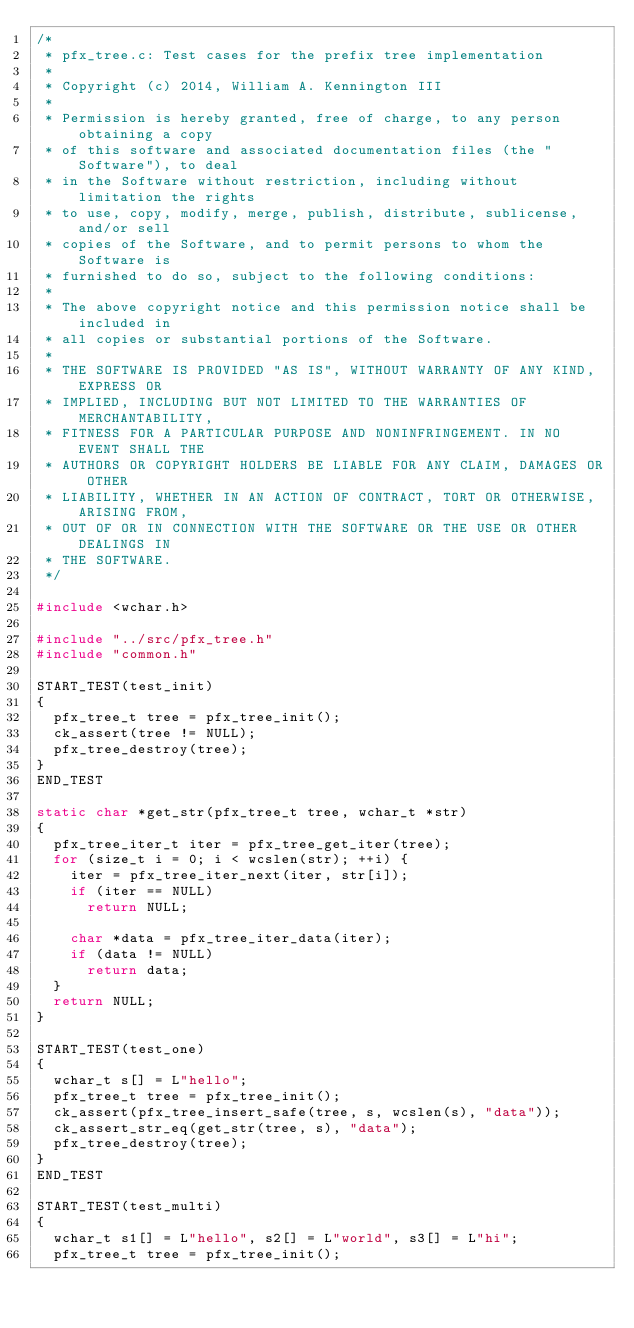Convert code to text. <code><loc_0><loc_0><loc_500><loc_500><_C_>/*
 * pfx_tree.c: Test cases for the prefix tree implementation
 *
 * Copyright (c) 2014, William A. Kennington III
 *
 * Permission is hereby granted, free of charge, to any person obtaining a copy
 * of this software and associated documentation files (the "Software"), to deal
 * in the Software without restriction, including without limitation the rights
 * to use, copy, modify, merge, publish, distribute, sublicense, and/or sell
 * copies of the Software, and to permit persons to whom the Software is
 * furnished to do so, subject to the following conditions:
 *
 * The above copyright notice and this permission notice shall be included in
 * all copies or substantial portions of the Software.
 *
 * THE SOFTWARE IS PROVIDED "AS IS", WITHOUT WARRANTY OF ANY KIND, EXPRESS OR
 * IMPLIED, INCLUDING BUT NOT LIMITED TO THE WARRANTIES OF MERCHANTABILITY,
 * FITNESS FOR A PARTICULAR PURPOSE AND NONINFRINGEMENT. IN NO EVENT SHALL THE
 * AUTHORS OR COPYRIGHT HOLDERS BE LIABLE FOR ANY CLAIM, DAMAGES OR OTHER
 * LIABILITY, WHETHER IN AN ACTION OF CONTRACT, TORT OR OTHERWISE, ARISING FROM,
 * OUT OF OR IN CONNECTION WITH THE SOFTWARE OR THE USE OR OTHER DEALINGS IN
 * THE SOFTWARE.
 */

#include <wchar.h>

#include "../src/pfx_tree.h"
#include "common.h"

START_TEST(test_init)
{
	pfx_tree_t tree = pfx_tree_init();
	ck_assert(tree != NULL);
	pfx_tree_destroy(tree);
}
END_TEST

static char *get_str(pfx_tree_t tree, wchar_t *str)
{
	pfx_tree_iter_t iter = pfx_tree_get_iter(tree);
	for (size_t i = 0; i < wcslen(str); ++i) {
		iter = pfx_tree_iter_next(iter, str[i]);
		if (iter == NULL)
			return NULL;

		char *data = pfx_tree_iter_data(iter);
		if (data != NULL)
			return data;
	}
	return NULL;
}

START_TEST(test_one)
{
	wchar_t s[] = L"hello";
	pfx_tree_t tree = pfx_tree_init();
	ck_assert(pfx_tree_insert_safe(tree, s, wcslen(s), "data"));
	ck_assert_str_eq(get_str(tree, s), "data");
	pfx_tree_destroy(tree);
}
END_TEST

START_TEST(test_multi)
{
	wchar_t s1[] = L"hello", s2[] = L"world", s3[] = L"hi";
	pfx_tree_t tree = pfx_tree_init();</code> 